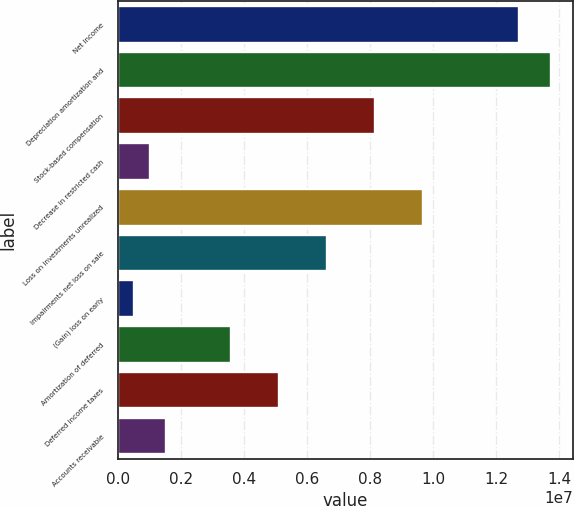<chart> <loc_0><loc_0><loc_500><loc_500><bar_chart><fcel>Net income<fcel>Depreciation amortization and<fcel>Stock-based compensation<fcel>Decrease in restricted cash<fcel>Loss on investments unrealized<fcel>Impairments net loss on sale<fcel>(Gain) loss on early<fcel>Amortization of deferred<fcel>Deferred income taxes<fcel>Accounts receivable<nl><fcel>1.27332e+07<fcel>1.37518e+07<fcel>8.14955e+06<fcel>1.01935e+06<fcel>9.67744e+06<fcel>6.62165e+06<fcel>510050<fcel>3.56585e+06<fcel>5.09375e+06<fcel>1.52865e+06<nl></chart> 